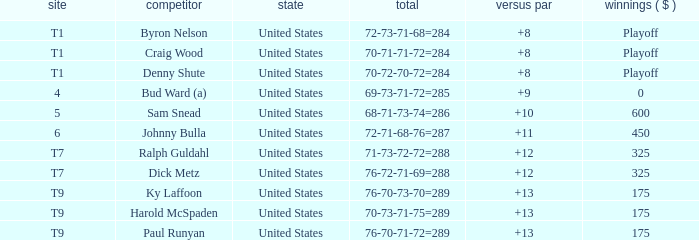What's the money that Sam Snead won? 600.0. 